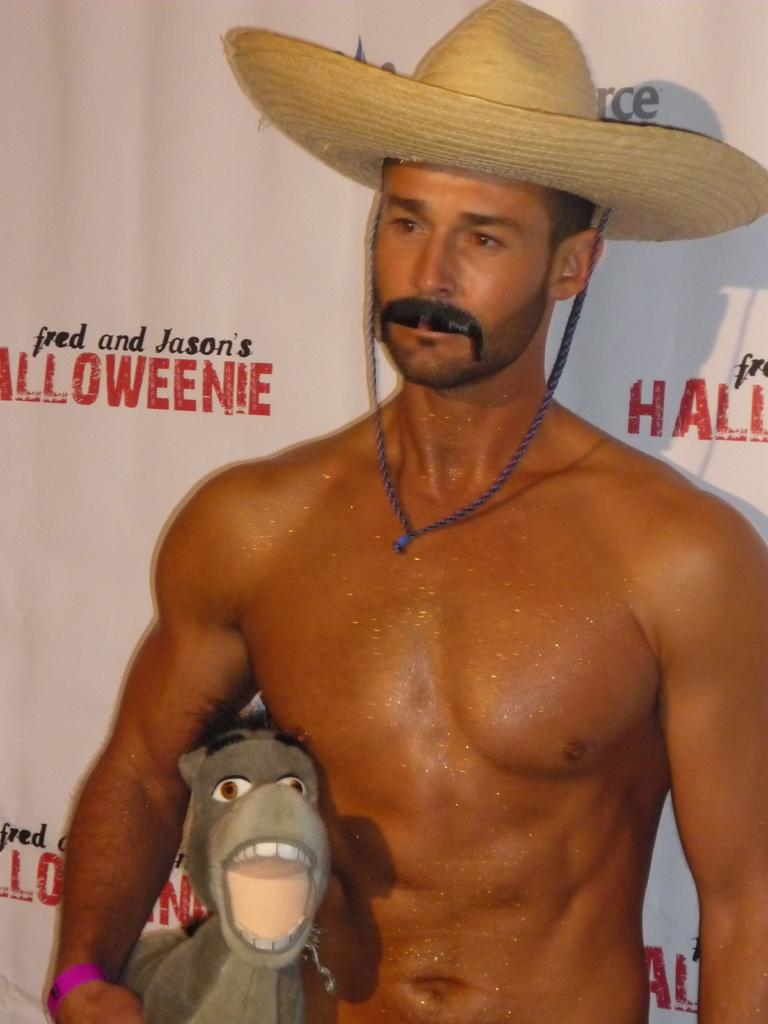What is the main subject of the image? The main subject of the image is a man. What is the man doing in the image? The man is standing in the image. What is the man wearing on his head? The man is wearing a hat in the image. What object is the man holding in his hand? The man is holding a toy in his hand in the image. What can be seen in the background of the image? There is a poster in the background of the image. What is written or depicted on the poster? There is text on the poster in the image. How many pigs are visible in the image? There are no pigs present in the image. What type of beast is depicted on the poster? There is no beast depicted on the poster; it contains text. 